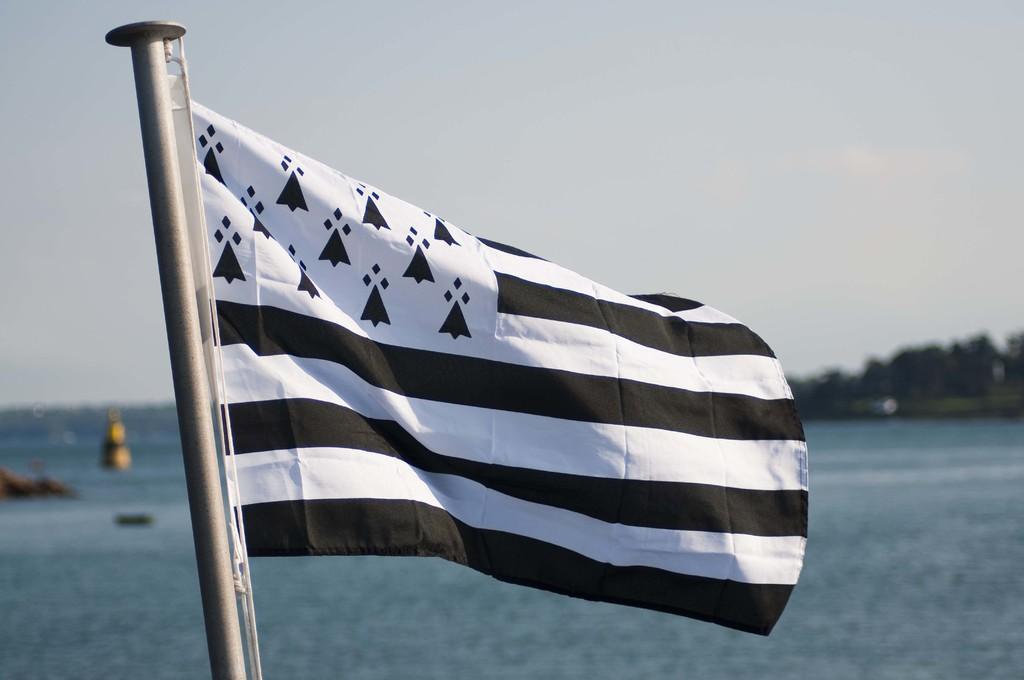How would you summarize this image in a sentence or two? It is a flag which is in black and white color and this is water. At the top it's a sky. 